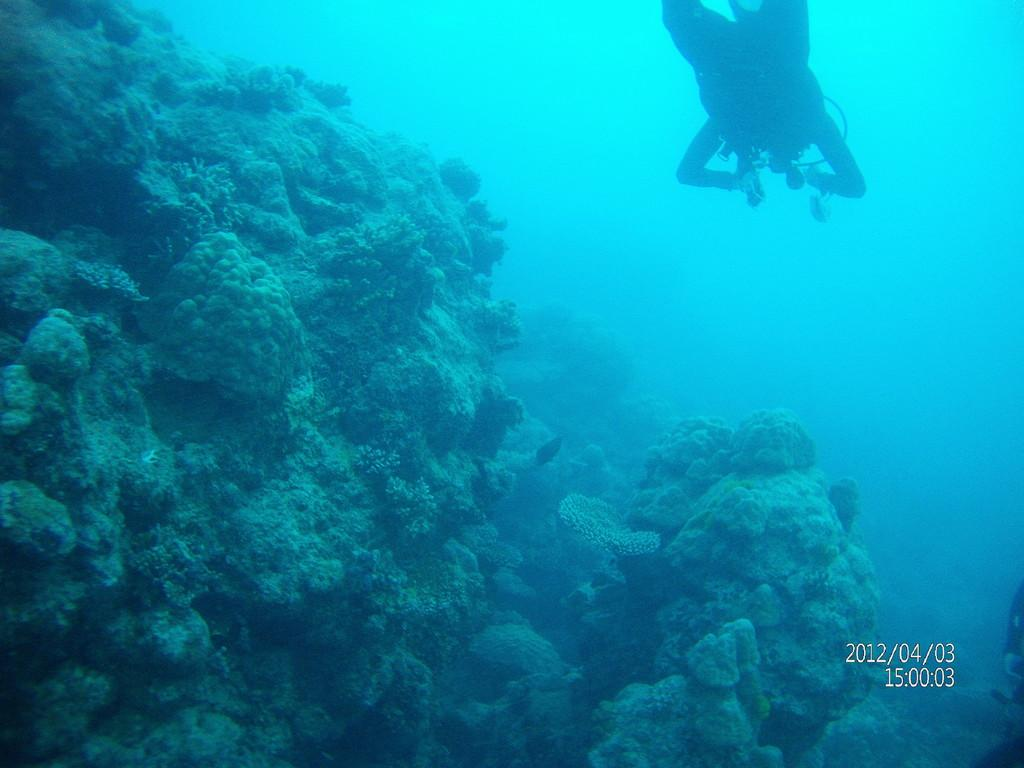What is the person in the image doing? There is a person swimming in the water. What can be seen underwater in the image? There are underwater plants visible. Is there any text present on the image? Yes, there is text present on the image. What story does the sun tell in the image? There is no sun present in the image, and therefore no story can be told by it. 